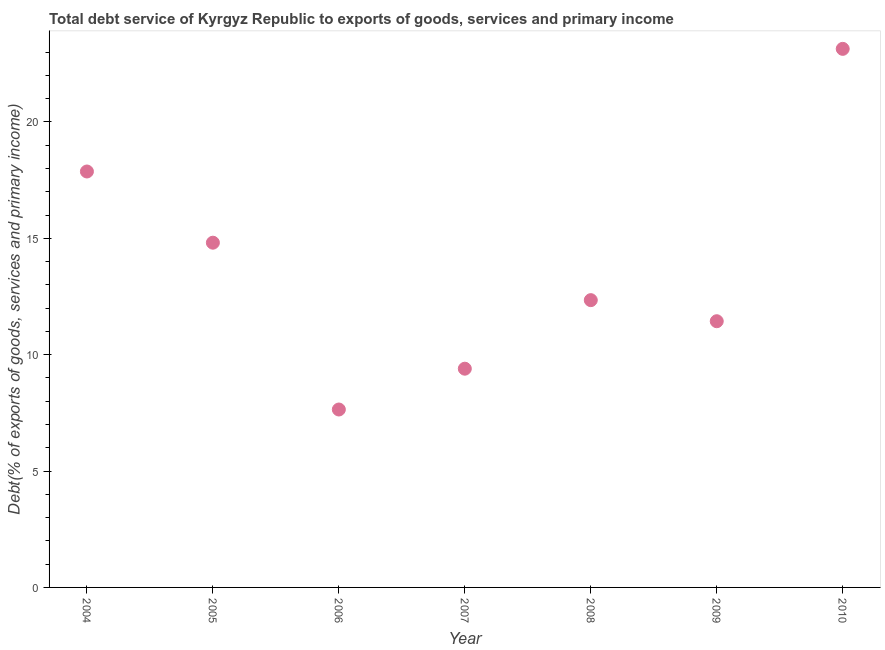What is the total debt service in 2009?
Keep it short and to the point. 11.44. Across all years, what is the maximum total debt service?
Provide a short and direct response. 23.14. Across all years, what is the minimum total debt service?
Your answer should be very brief. 7.64. In which year was the total debt service maximum?
Give a very brief answer. 2010. What is the sum of the total debt service?
Keep it short and to the point. 96.64. What is the difference between the total debt service in 2004 and 2005?
Provide a short and direct response. 3.06. What is the average total debt service per year?
Keep it short and to the point. 13.81. What is the median total debt service?
Ensure brevity in your answer.  12.34. In how many years, is the total debt service greater than 7 %?
Offer a very short reply. 7. What is the ratio of the total debt service in 2005 to that in 2009?
Offer a terse response. 1.29. Is the difference between the total debt service in 2007 and 2010 greater than the difference between any two years?
Your answer should be compact. No. What is the difference between the highest and the second highest total debt service?
Offer a terse response. 5.27. Is the sum of the total debt service in 2009 and 2010 greater than the maximum total debt service across all years?
Ensure brevity in your answer.  Yes. What is the difference between the highest and the lowest total debt service?
Make the answer very short. 15.5. Does the total debt service monotonically increase over the years?
Ensure brevity in your answer.  No. How many dotlines are there?
Ensure brevity in your answer.  1. How many years are there in the graph?
Keep it short and to the point. 7. Are the values on the major ticks of Y-axis written in scientific E-notation?
Provide a succinct answer. No. Does the graph contain any zero values?
Provide a short and direct response. No. Does the graph contain grids?
Your answer should be very brief. No. What is the title of the graph?
Your answer should be very brief. Total debt service of Kyrgyz Republic to exports of goods, services and primary income. What is the label or title of the X-axis?
Offer a very short reply. Year. What is the label or title of the Y-axis?
Keep it short and to the point. Debt(% of exports of goods, services and primary income). What is the Debt(% of exports of goods, services and primary income) in 2004?
Your answer should be compact. 17.87. What is the Debt(% of exports of goods, services and primary income) in 2005?
Ensure brevity in your answer.  14.81. What is the Debt(% of exports of goods, services and primary income) in 2006?
Offer a terse response. 7.64. What is the Debt(% of exports of goods, services and primary income) in 2007?
Your response must be concise. 9.4. What is the Debt(% of exports of goods, services and primary income) in 2008?
Offer a terse response. 12.34. What is the Debt(% of exports of goods, services and primary income) in 2009?
Your answer should be compact. 11.44. What is the Debt(% of exports of goods, services and primary income) in 2010?
Offer a very short reply. 23.14. What is the difference between the Debt(% of exports of goods, services and primary income) in 2004 and 2005?
Ensure brevity in your answer.  3.06. What is the difference between the Debt(% of exports of goods, services and primary income) in 2004 and 2006?
Give a very brief answer. 10.23. What is the difference between the Debt(% of exports of goods, services and primary income) in 2004 and 2007?
Make the answer very short. 8.47. What is the difference between the Debt(% of exports of goods, services and primary income) in 2004 and 2008?
Provide a short and direct response. 5.53. What is the difference between the Debt(% of exports of goods, services and primary income) in 2004 and 2009?
Ensure brevity in your answer.  6.43. What is the difference between the Debt(% of exports of goods, services and primary income) in 2004 and 2010?
Make the answer very short. -5.27. What is the difference between the Debt(% of exports of goods, services and primary income) in 2005 and 2006?
Provide a succinct answer. 7.17. What is the difference between the Debt(% of exports of goods, services and primary income) in 2005 and 2007?
Provide a succinct answer. 5.41. What is the difference between the Debt(% of exports of goods, services and primary income) in 2005 and 2008?
Make the answer very short. 2.47. What is the difference between the Debt(% of exports of goods, services and primary income) in 2005 and 2009?
Your response must be concise. 3.37. What is the difference between the Debt(% of exports of goods, services and primary income) in 2005 and 2010?
Offer a terse response. -8.33. What is the difference between the Debt(% of exports of goods, services and primary income) in 2006 and 2007?
Your response must be concise. -1.75. What is the difference between the Debt(% of exports of goods, services and primary income) in 2006 and 2008?
Give a very brief answer. -4.7. What is the difference between the Debt(% of exports of goods, services and primary income) in 2006 and 2009?
Your answer should be very brief. -3.79. What is the difference between the Debt(% of exports of goods, services and primary income) in 2006 and 2010?
Ensure brevity in your answer.  -15.5. What is the difference between the Debt(% of exports of goods, services and primary income) in 2007 and 2008?
Keep it short and to the point. -2.95. What is the difference between the Debt(% of exports of goods, services and primary income) in 2007 and 2009?
Provide a short and direct response. -2.04. What is the difference between the Debt(% of exports of goods, services and primary income) in 2007 and 2010?
Make the answer very short. -13.74. What is the difference between the Debt(% of exports of goods, services and primary income) in 2008 and 2009?
Ensure brevity in your answer.  0.91. What is the difference between the Debt(% of exports of goods, services and primary income) in 2008 and 2010?
Your answer should be very brief. -10.8. What is the difference between the Debt(% of exports of goods, services and primary income) in 2009 and 2010?
Keep it short and to the point. -11.7. What is the ratio of the Debt(% of exports of goods, services and primary income) in 2004 to that in 2005?
Your response must be concise. 1.21. What is the ratio of the Debt(% of exports of goods, services and primary income) in 2004 to that in 2006?
Offer a very short reply. 2.34. What is the ratio of the Debt(% of exports of goods, services and primary income) in 2004 to that in 2007?
Provide a succinct answer. 1.9. What is the ratio of the Debt(% of exports of goods, services and primary income) in 2004 to that in 2008?
Ensure brevity in your answer.  1.45. What is the ratio of the Debt(% of exports of goods, services and primary income) in 2004 to that in 2009?
Ensure brevity in your answer.  1.56. What is the ratio of the Debt(% of exports of goods, services and primary income) in 2004 to that in 2010?
Give a very brief answer. 0.77. What is the ratio of the Debt(% of exports of goods, services and primary income) in 2005 to that in 2006?
Your response must be concise. 1.94. What is the ratio of the Debt(% of exports of goods, services and primary income) in 2005 to that in 2007?
Give a very brief answer. 1.58. What is the ratio of the Debt(% of exports of goods, services and primary income) in 2005 to that in 2008?
Give a very brief answer. 1.2. What is the ratio of the Debt(% of exports of goods, services and primary income) in 2005 to that in 2009?
Keep it short and to the point. 1.29. What is the ratio of the Debt(% of exports of goods, services and primary income) in 2005 to that in 2010?
Offer a very short reply. 0.64. What is the ratio of the Debt(% of exports of goods, services and primary income) in 2006 to that in 2007?
Keep it short and to the point. 0.81. What is the ratio of the Debt(% of exports of goods, services and primary income) in 2006 to that in 2008?
Offer a terse response. 0.62. What is the ratio of the Debt(% of exports of goods, services and primary income) in 2006 to that in 2009?
Make the answer very short. 0.67. What is the ratio of the Debt(% of exports of goods, services and primary income) in 2006 to that in 2010?
Your answer should be very brief. 0.33. What is the ratio of the Debt(% of exports of goods, services and primary income) in 2007 to that in 2008?
Ensure brevity in your answer.  0.76. What is the ratio of the Debt(% of exports of goods, services and primary income) in 2007 to that in 2009?
Your response must be concise. 0.82. What is the ratio of the Debt(% of exports of goods, services and primary income) in 2007 to that in 2010?
Provide a short and direct response. 0.41. What is the ratio of the Debt(% of exports of goods, services and primary income) in 2008 to that in 2009?
Offer a very short reply. 1.08. What is the ratio of the Debt(% of exports of goods, services and primary income) in 2008 to that in 2010?
Offer a very short reply. 0.53. What is the ratio of the Debt(% of exports of goods, services and primary income) in 2009 to that in 2010?
Ensure brevity in your answer.  0.49. 